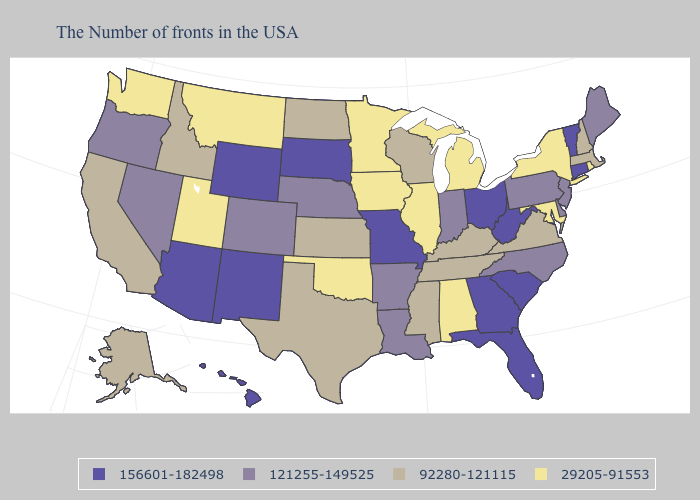Does Minnesota have a lower value than New York?
Concise answer only. No. Does Wyoming have the highest value in the USA?
Short answer required. Yes. Which states hav the highest value in the Northeast?
Short answer required. Vermont, Connecticut. Does the first symbol in the legend represent the smallest category?
Quick response, please. No. Does the map have missing data?
Give a very brief answer. No. What is the highest value in states that border Illinois?
Write a very short answer. 156601-182498. Name the states that have a value in the range 121255-149525?
Short answer required. Maine, New Jersey, Delaware, Pennsylvania, North Carolina, Indiana, Louisiana, Arkansas, Nebraska, Colorado, Nevada, Oregon. Name the states that have a value in the range 121255-149525?
Be succinct. Maine, New Jersey, Delaware, Pennsylvania, North Carolina, Indiana, Louisiana, Arkansas, Nebraska, Colorado, Nevada, Oregon. What is the value of Virginia?
Concise answer only. 92280-121115. Which states hav the highest value in the Northeast?
Quick response, please. Vermont, Connecticut. Which states have the lowest value in the USA?
Be succinct. Rhode Island, New York, Maryland, Michigan, Alabama, Illinois, Minnesota, Iowa, Oklahoma, Utah, Montana, Washington. What is the highest value in the South ?
Answer briefly. 156601-182498. Among the states that border Virginia , does North Carolina have the lowest value?
Write a very short answer. No. What is the value of Utah?
Short answer required. 29205-91553. 